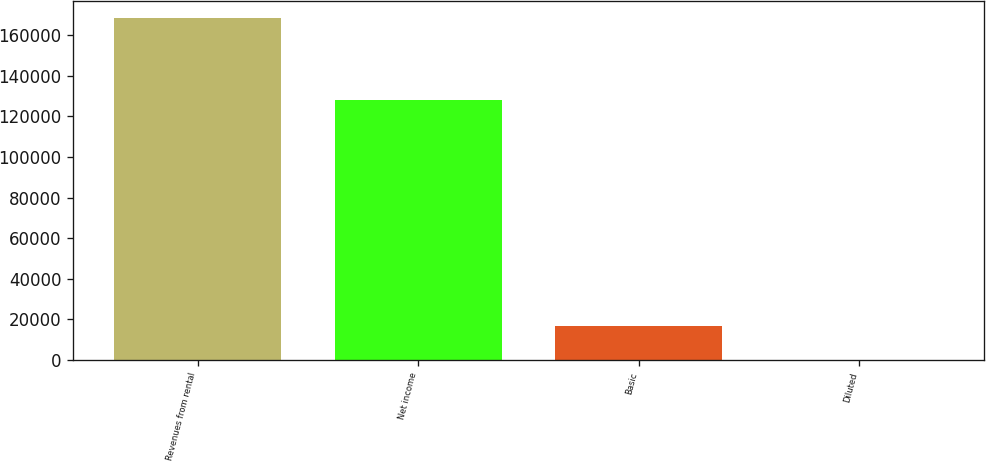Convert chart to OTSL. <chart><loc_0><loc_0><loc_500><loc_500><bar_chart><fcel>Revenues from rental<fcel>Net income<fcel>Basic<fcel>Diluted<nl><fcel>168448<fcel>128022<fcel>16845.2<fcel>0.49<nl></chart> 